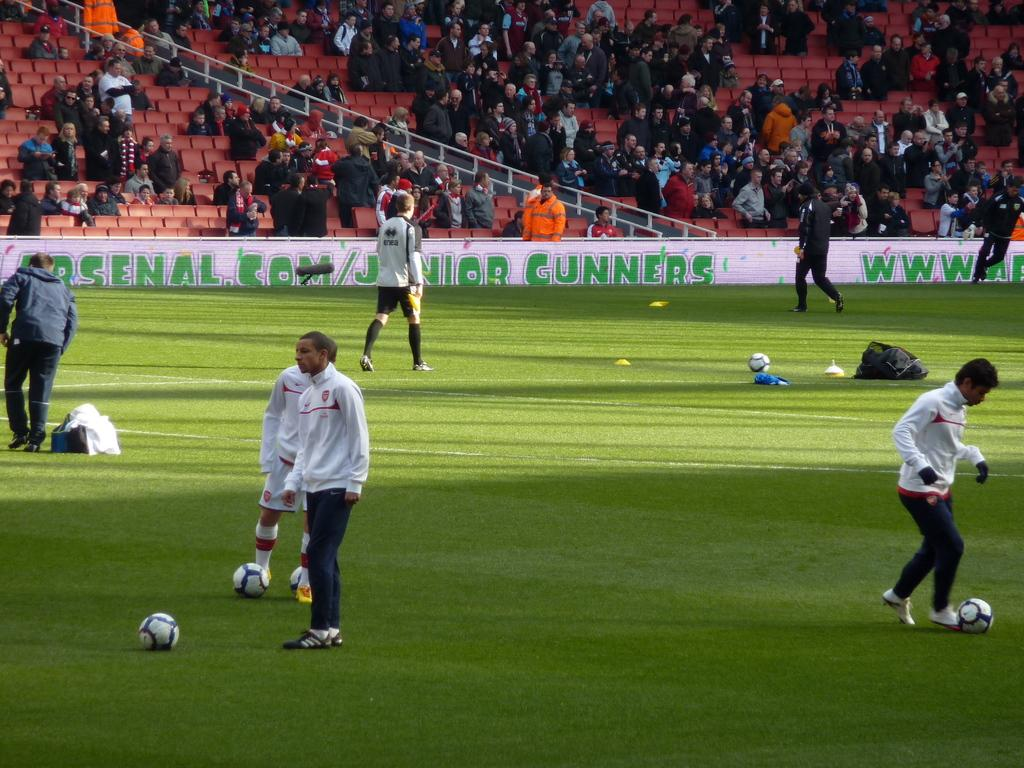How many people are in the image? There is a group of people in the image. What are some of the people doing in the image? Some people are sitting on chairs, while others are standing in a ground. What activity are they engaged in? They are playing a game. What can be seen in the background of the image? There is a banner visible in the background. What type of clouds can be seen in the image? There are no clouds visible in the image; it is focused on the group of people playing a game. 